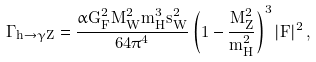<formula> <loc_0><loc_0><loc_500><loc_500>\Gamma _ { h \rightarrow \gamma Z } = \frac { \alpha G _ { F } ^ { 2 } M _ { W } ^ { 2 } m _ { H } ^ { 3 } s _ { W } ^ { 2 } } { 6 4 \pi ^ { 4 } } \left ( 1 - \frac { M _ { Z } ^ { 2 } } { m _ { H } ^ { 2 } } \right ) ^ { 3 } | F | ^ { 2 } \, ,</formula> 